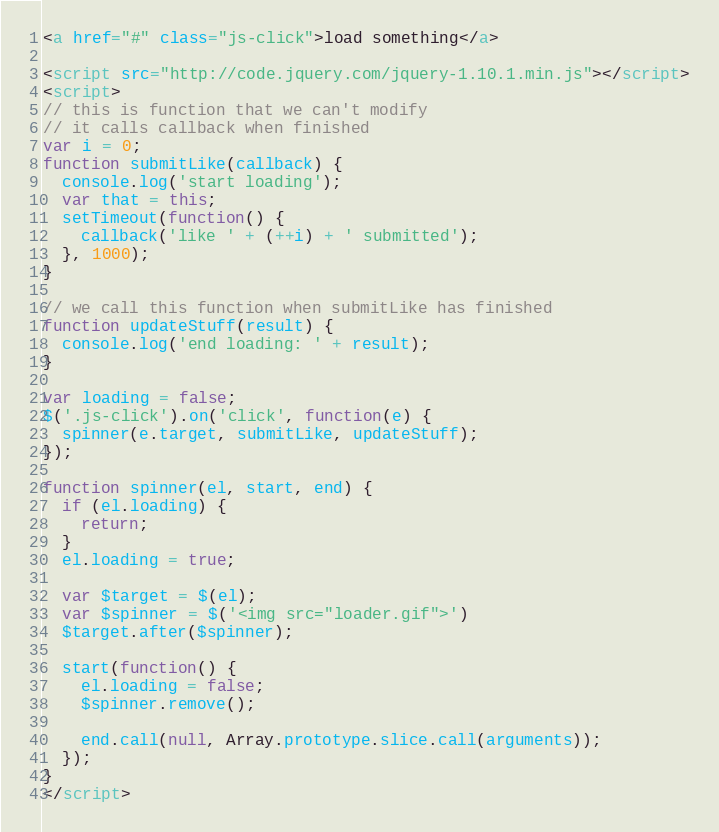Convert code to text. <code><loc_0><loc_0><loc_500><loc_500><_HTML_><a href="#" class="js-click">load something</a>

<script src="http://code.jquery.com/jquery-1.10.1.min.js"></script>
<script>
// this is function that we can't modify
// it calls callback when finished
var i = 0;
function submitLike(callback) {
  console.log('start loading');
  var that = this;
  setTimeout(function() {
    callback('like ' + (++i) + ' submitted');
  }, 1000);
}

// we call this function when submitLike has finished
function updateStuff(result) {
  console.log('end loading: ' + result);
}

var loading = false;
$('.js-click').on('click', function(e) {
  spinner(e.target, submitLike, updateStuff);
});

function spinner(el, start, end) {
  if (el.loading) {
    return;
  }
  el.loading = true;

  var $target = $(el);
  var $spinner = $('<img src="loader.gif">')
  $target.after($spinner);

  start(function() {
    el.loading = false;
    $spinner.remove();
    
    end.call(null, Array.prototype.slice.call(arguments));
  });
}
</script>
</code> 